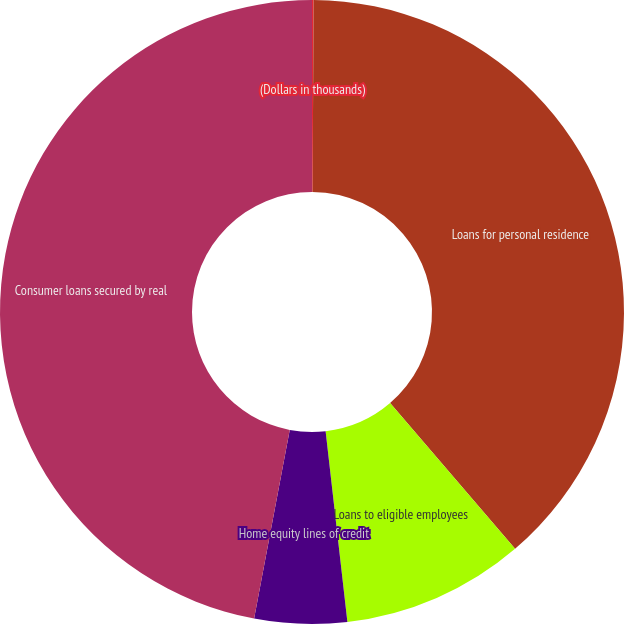<chart> <loc_0><loc_0><loc_500><loc_500><pie_chart><fcel>(Dollars in thousands)<fcel>Loans for personal residence<fcel>Loans to eligible employees<fcel>Home equity lines of credit<fcel>Consumer loans secured by real<nl><fcel>0.08%<fcel>38.64%<fcel>9.47%<fcel>4.78%<fcel>47.03%<nl></chart> 